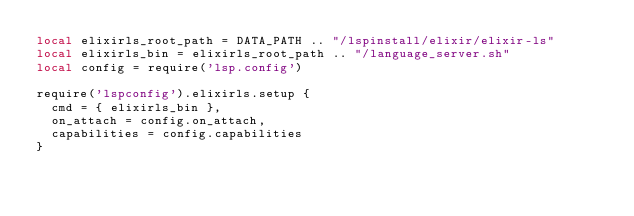<code> <loc_0><loc_0><loc_500><loc_500><_Lua_>local elixirls_root_path = DATA_PATH .. "/lspinstall/elixir/elixir-ls"
local elixirls_bin = elixirls_root_path .. "/language_server.sh"
local config = require('lsp.config')

require('lspconfig').elixirls.setup {
  cmd = { elixirls_bin },
  on_attach = config.on_attach,
  capabilities = config.capabilities
}
</code> 